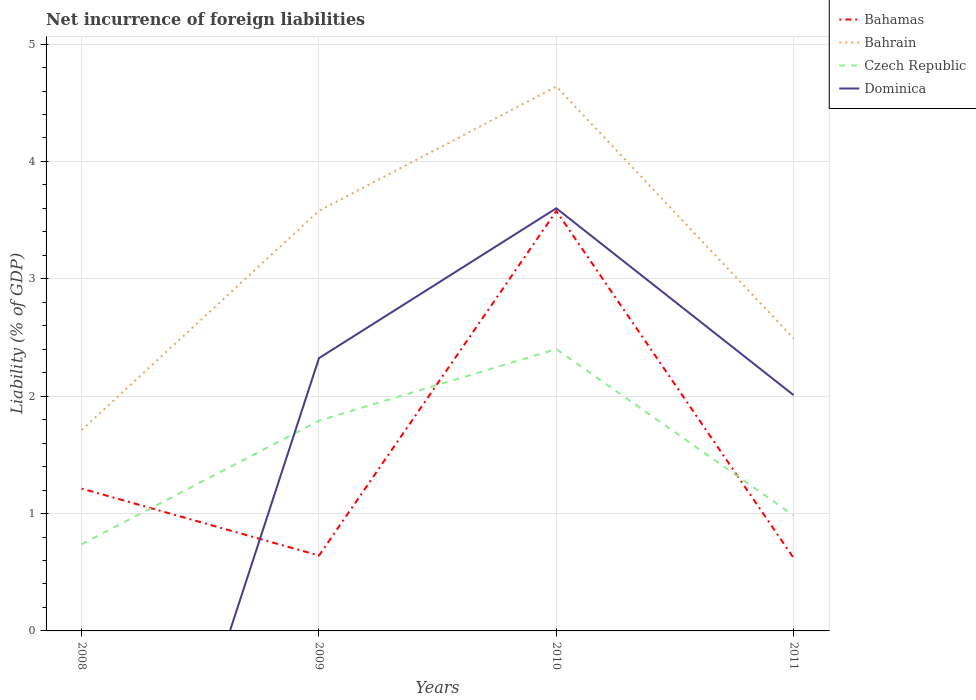How many different coloured lines are there?
Ensure brevity in your answer.  4. Is the number of lines equal to the number of legend labels?
Offer a very short reply. No. Across all years, what is the maximum net incurrence of foreign liabilities in Bahrain?
Your answer should be very brief. 1.71. What is the total net incurrence of foreign liabilities in Bahrain in the graph?
Offer a very short reply. -0.78. What is the difference between the highest and the second highest net incurrence of foreign liabilities in Bahrain?
Offer a terse response. 2.93. Is the net incurrence of foreign liabilities in Bahrain strictly greater than the net incurrence of foreign liabilities in Bahamas over the years?
Keep it short and to the point. No. How many lines are there?
Provide a short and direct response. 4. How many years are there in the graph?
Keep it short and to the point. 4. Does the graph contain grids?
Make the answer very short. Yes. Where does the legend appear in the graph?
Your answer should be very brief. Top right. How are the legend labels stacked?
Make the answer very short. Vertical. What is the title of the graph?
Provide a short and direct response. Net incurrence of foreign liabilities. Does "French Polynesia" appear as one of the legend labels in the graph?
Offer a terse response. No. What is the label or title of the Y-axis?
Your response must be concise. Liability (% of GDP). What is the Liability (% of GDP) of Bahamas in 2008?
Provide a short and direct response. 1.21. What is the Liability (% of GDP) of Bahrain in 2008?
Your response must be concise. 1.71. What is the Liability (% of GDP) of Czech Republic in 2008?
Give a very brief answer. 0.74. What is the Liability (% of GDP) in Dominica in 2008?
Make the answer very short. 0. What is the Liability (% of GDP) in Bahamas in 2009?
Ensure brevity in your answer.  0.64. What is the Liability (% of GDP) in Bahrain in 2009?
Your response must be concise. 3.58. What is the Liability (% of GDP) in Czech Republic in 2009?
Provide a succinct answer. 1.79. What is the Liability (% of GDP) in Dominica in 2009?
Give a very brief answer. 2.32. What is the Liability (% of GDP) in Bahamas in 2010?
Your answer should be very brief. 3.58. What is the Liability (% of GDP) of Bahrain in 2010?
Give a very brief answer. 4.64. What is the Liability (% of GDP) of Czech Republic in 2010?
Provide a short and direct response. 2.4. What is the Liability (% of GDP) in Dominica in 2010?
Offer a terse response. 3.6. What is the Liability (% of GDP) in Bahamas in 2011?
Your answer should be compact. 0.62. What is the Liability (% of GDP) of Bahrain in 2011?
Ensure brevity in your answer.  2.49. What is the Liability (% of GDP) in Czech Republic in 2011?
Provide a succinct answer. 0.98. What is the Liability (% of GDP) of Dominica in 2011?
Ensure brevity in your answer.  2.01. Across all years, what is the maximum Liability (% of GDP) of Bahamas?
Ensure brevity in your answer.  3.58. Across all years, what is the maximum Liability (% of GDP) of Bahrain?
Your response must be concise. 4.64. Across all years, what is the maximum Liability (% of GDP) in Czech Republic?
Give a very brief answer. 2.4. Across all years, what is the maximum Liability (% of GDP) of Dominica?
Your answer should be very brief. 3.6. Across all years, what is the minimum Liability (% of GDP) in Bahamas?
Provide a short and direct response. 0.62. Across all years, what is the minimum Liability (% of GDP) of Bahrain?
Your response must be concise. 1.71. Across all years, what is the minimum Liability (% of GDP) of Czech Republic?
Provide a short and direct response. 0.74. What is the total Liability (% of GDP) in Bahamas in the graph?
Ensure brevity in your answer.  6.05. What is the total Liability (% of GDP) in Bahrain in the graph?
Ensure brevity in your answer.  12.42. What is the total Liability (% of GDP) in Czech Republic in the graph?
Give a very brief answer. 5.91. What is the total Liability (% of GDP) of Dominica in the graph?
Provide a short and direct response. 7.93. What is the difference between the Liability (% of GDP) of Bahamas in 2008 and that in 2009?
Your answer should be very brief. 0.57. What is the difference between the Liability (% of GDP) of Bahrain in 2008 and that in 2009?
Keep it short and to the point. -1.87. What is the difference between the Liability (% of GDP) of Czech Republic in 2008 and that in 2009?
Your response must be concise. -1.05. What is the difference between the Liability (% of GDP) of Bahamas in 2008 and that in 2010?
Ensure brevity in your answer.  -2.36. What is the difference between the Liability (% of GDP) of Bahrain in 2008 and that in 2010?
Your answer should be very brief. -2.93. What is the difference between the Liability (% of GDP) of Czech Republic in 2008 and that in 2010?
Make the answer very short. -1.66. What is the difference between the Liability (% of GDP) in Bahamas in 2008 and that in 2011?
Your response must be concise. 0.59. What is the difference between the Liability (% of GDP) of Bahrain in 2008 and that in 2011?
Make the answer very short. -0.78. What is the difference between the Liability (% of GDP) of Czech Republic in 2008 and that in 2011?
Your answer should be very brief. -0.25. What is the difference between the Liability (% of GDP) of Bahamas in 2009 and that in 2010?
Give a very brief answer. -2.94. What is the difference between the Liability (% of GDP) in Bahrain in 2009 and that in 2010?
Your answer should be compact. -1.06. What is the difference between the Liability (% of GDP) of Czech Republic in 2009 and that in 2010?
Provide a short and direct response. -0.61. What is the difference between the Liability (% of GDP) of Dominica in 2009 and that in 2010?
Ensure brevity in your answer.  -1.28. What is the difference between the Liability (% of GDP) in Bahamas in 2009 and that in 2011?
Your answer should be compact. 0.02. What is the difference between the Liability (% of GDP) of Bahrain in 2009 and that in 2011?
Provide a short and direct response. 1.09. What is the difference between the Liability (% of GDP) in Czech Republic in 2009 and that in 2011?
Give a very brief answer. 0.81. What is the difference between the Liability (% of GDP) in Dominica in 2009 and that in 2011?
Give a very brief answer. 0.32. What is the difference between the Liability (% of GDP) in Bahamas in 2010 and that in 2011?
Make the answer very short. 2.96. What is the difference between the Liability (% of GDP) of Bahrain in 2010 and that in 2011?
Make the answer very short. 2.15. What is the difference between the Liability (% of GDP) in Czech Republic in 2010 and that in 2011?
Your response must be concise. 1.42. What is the difference between the Liability (% of GDP) in Dominica in 2010 and that in 2011?
Offer a terse response. 1.59. What is the difference between the Liability (% of GDP) in Bahamas in 2008 and the Liability (% of GDP) in Bahrain in 2009?
Your answer should be compact. -2.37. What is the difference between the Liability (% of GDP) in Bahamas in 2008 and the Liability (% of GDP) in Czech Republic in 2009?
Give a very brief answer. -0.58. What is the difference between the Liability (% of GDP) in Bahamas in 2008 and the Liability (% of GDP) in Dominica in 2009?
Your answer should be compact. -1.11. What is the difference between the Liability (% of GDP) in Bahrain in 2008 and the Liability (% of GDP) in Czech Republic in 2009?
Ensure brevity in your answer.  -0.08. What is the difference between the Liability (% of GDP) of Bahrain in 2008 and the Liability (% of GDP) of Dominica in 2009?
Your answer should be very brief. -0.61. What is the difference between the Liability (% of GDP) in Czech Republic in 2008 and the Liability (% of GDP) in Dominica in 2009?
Your response must be concise. -1.59. What is the difference between the Liability (% of GDP) of Bahamas in 2008 and the Liability (% of GDP) of Bahrain in 2010?
Offer a very short reply. -3.43. What is the difference between the Liability (% of GDP) in Bahamas in 2008 and the Liability (% of GDP) in Czech Republic in 2010?
Your response must be concise. -1.19. What is the difference between the Liability (% of GDP) of Bahamas in 2008 and the Liability (% of GDP) of Dominica in 2010?
Provide a succinct answer. -2.39. What is the difference between the Liability (% of GDP) in Bahrain in 2008 and the Liability (% of GDP) in Czech Republic in 2010?
Ensure brevity in your answer.  -0.69. What is the difference between the Liability (% of GDP) of Bahrain in 2008 and the Liability (% of GDP) of Dominica in 2010?
Keep it short and to the point. -1.89. What is the difference between the Liability (% of GDP) of Czech Republic in 2008 and the Liability (% of GDP) of Dominica in 2010?
Make the answer very short. -2.86. What is the difference between the Liability (% of GDP) in Bahamas in 2008 and the Liability (% of GDP) in Bahrain in 2011?
Your response must be concise. -1.28. What is the difference between the Liability (% of GDP) of Bahamas in 2008 and the Liability (% of GDP) of Czech Republic in 2011?
Make the answer very short. 0.23. What is the difference between the Liability (% of GDP) in Bahamas in 2008 and the Liability (% of GDP) in Dominica in 2011?
Provide a succinct answer. -0.8. What is the difference between the Liability (% of GDP) in Bahrain in 2008 and the Liability (% of GDP) in Czech Republic in 2011?
Your answer should be compact. 0.73. What is the difference between the Liability (% of GDP) of Bahrain in 2008 and the Liability (% of GDP) of Dominica in 2011?
Your response must be concise. -0.3. What is the difference between the Liability (% of GDP) in Czech Republic in 2008 and the Liability (% of GDP) in Dominica in 2011?
Make the answer very short. -1.27. What is the difference between the Liability (% of GDP) in Bahamas in 2009 and the Liability (% of GDP) in Bahrain in 2010?
Your response must be concise. -4. What is the difference between the Liability (% of GDP) in Bahamas in 2009 and the Liability (% of GDP) in Czech Republic in 2010?
Keep it short and to the point. -1.76. What is the difference between the Liability (% of GDP) in Bahamas in 2009 and the Liability (% of GDP) in Dominica in 2010?
Make the answer very short. -2.96. What is the difference between the Liability (% of GDP) in Bahrain in 2009 and the Liability (% of GDP) in Czech Republic in 2010?
Your response must be concise. 1.18. What is the difference between the Liability (% of GDP) of Bahrain in 2009 and the Liability (% of GDP) of Dominica in 2010?
Provide a succinct answer. -0.02. What is the difference between the Liability (% of GDP) of Czech Republic in 2009 and the Liability (% of GDP) of Dominica in 2010?
Keep it short and to the point. -1.81. What is the difference between the Liability (% of GDP) in Bahamas in 2009 and the Liability (% of GDP) in Bahrain in 2011?
Provide a short and direct response. -1.85. What is the difference between the Liability (% of GDP) in Bahamas in 2009 and the Liability (% of GDP) in Czech Republic in 2011?
Give a very brief answer. -0.34. What is the difference between the Liability (% of GDP) of Bahamas in 2009 and the Liability (% of GDP) of Dominica in 2011?
Offer a very short reply. -1.37. What is the difference between the Liability (% of GDP) in Bahrain in 2009 and the Liability (% of GDP) in Czech Republic in 2011?
Offer a terse response. 2.6. What is the difference between the Liability (% of GDP) of Bahrain in 2009 and the Liability (% of GDP) of Dominica in 2011?
Offer a terse response. 1.57. What is the difference between the Liability (% of GDP) in Czech Republic in 2009 and the Liability (% of GDP) in Dominica in 2011?
Offer a very short reply. -0.22. What is the difference between the Liability (% of GDP) in Bahamas in 2010 and the Liability (% of GDP) in Bahrain in 2011?
Provide a short and direct response. 1.09. What is the difference between the Liability (% of GDP) in Bahamas in 2010 and the Liability (% of GDP) in Czech Republic in 2011?
Your answer should be very brief. 2.59. What is the difference between the Liability (% of GDP) in Bahamas in 2010 and the Liability (% of GDP) in Dominica in 2011?
Provide a short and direct response. 1.57. What is the difference between the Liability (% of GDP) in Bahrain in 2010 and the Liability (% of GDP) in Czech Republic in 2011?
Make the answer very short. 3.65. What is the difference between the Liability (% of GDP) of Bahrain in 2010 and the Liability (% of GDP) of Dominica in 2011?
Offer a terse response. 2.63. What is the difference between the Liability (% of GDP) in Czech Republic in 2010 and the Liability (% of GDP) in Dominica in 2011?
Offer a terse response. 0.39. What is the average Liability (% of GDP) of Bahamas per year?
Keep it short and to the point. 1.51. What is the average Liability (% of GDP) in Bahrain per year?
Make the answer very short. 3.11. What is the average Liability (% of GDP) in Czech Republic per year?
Offer a terse response. 1.48. What is the average Liability (% of GDP) in Dominica per year?
Keep it short and to the point. 1.98. In the year 2008, what is the difference between the Liability (% of GDP) of Bahamas and Liability (% of GDP) of Bahrain?
Keep it short and to the point. -0.5. In the year 2008, what is the difference between the Liability (% of GDP) in Bahamas and Liability (% of GDP) in Czech Republic?
Your answer should be compact. 0.47. In the year 2008, what is the difference between the Liability (% of GDP) of Bahrain and Liability (% of GDP) of Czech Republic?
Make the answer very short. 0.97. In the year 2009, what is the difference between the Liability (% of GDP) of Bahamas and Liability (% of GDP) of Bahrain?
Your response must be concise. -2.94. In the year 2009, what is the difference between the Liability (% of GDP) in Bahamas and Liability (% of GDP) in Czech Republic?
Your answer should be very brief. -1.15. In the year 2009, what is the difference between the Liability (% of GDP) in Bahamas and Liability (% of GDP) in Dominica?
Offer a very short reply. -1.68. In the year 2009, what is the difference between the Liability (% of GDP) in Bahrain and Liability (% of GDP) in Czech Republic?
Provide a short and direct response. 1.79. In the year 2009, what is the difference between the Liability (% of GDP) in Bahrain and Liability (% of GDP) in Dominica?
Make the answer very short. 1.26. In the year 2009, what is the difference between the Liability (% of GDP) in Czech Republic and Liability (% of GDP) in Dominica?
Your answer should be compact. -0.53. In the year 2010, what is the difference between the Liability (% of GDP) in Bahamas and Liability (% of GDP) in Bahrain?
Provide a succinct answer. -1.06. In the year 2010, what is the difference between the Liability (% of GDP) of Bahamas and Liability (% of GDP) of Czech Republic?
Provide a succinct answer. 1.18. In the year 2010, what is the difference between the Liability (% of GDP) of Bahamas and Liability (% of GDP) of Dominica?
Ensure brevity in your answer.  -0.02. In the year 2010, what is the difference between the Liability (% of GDP) of Bahrain and Liability (% of GDP) of Czech Republic?
Keep it short and to the point. 2.24. In the year 2010, what is the difference between the Liability (% of GDP) of Bahrain and Liability (% of GDP) of Dominica?
Make the answer very short. 1.04. In the year 2011, what is the difference between the Liability (% of GDP) in Bahamas and Liability (% of GDP) in Bahrain?
Your answer should be very brief. -1.87. In the year 2011, what is the difference between the Liability (% of GDP) of Bahamas and Liability (% of GDP) of Czech Republic?
Offer a terse response. -0.36. In the year 2011, what is the difference between the Liability (% of GDP) in Bahamas and Liability (% of GDP) in Dominica?
Provide a succinct answer. -1.39. In the year 2011, what is the difference between the Liability (% of GDP) in Bahrain and Liability (% of GDP) in Czech Republic?
Provide a short and direct response. 1.51. In the year 2011, what is the difference between the Liability (% of GDP) of Bahrain and Liability (% of GDP) of Dominica?
Ensure brevity in your answer.  0.48. In the year 2011, what is the difference between the Liability (% of GDP) of Czech Republic and Liability (% of GDP) of Dominica?
Your response must be concise. -1.03. What is the ratio of the Liability (% of GDP) of Bahamas in 2008 to that in 2009?
Make the answer very short. 1.89. What is the ratio of the Liability (% of GDP) in Bahrain in 2008 to that in 2009?
Your answer should be compact. 0.48. What is the ratio of the Liability (% of GDP) of Czech Republic in 2008 to that in 2009?
Make the answer very short. 0.41. What is the ratio of the Liability (% of GDP) of Bahamas in 2008 to that in 2010?
Offer a terse response. 0.34. What is the ratio of the Liability (% of GDP) of Bahrain in 2008 to that in 2010?
Provide a succinct answer. 0.37. What is the ratio of the Liability (% of GDP) of Czech Republic in 2008 to that in 2010?
Your answer should be very brief. 0.31. What is the ratio of the Liability (% of GDP) in Bahamas in 2008 to that in 2011?
Keep it short and to the point. 1.96. What is the ratio of the Liability (% of GDP) in Bahrain in 2008 to that in 2011?
Give a very brief answer. 0.69. What is the ratio of the Liability (% of GDP) of Czech Republic in 2008 to that in 2011?
Your answer should be compact. 0.75. What is the ratio of the Liability (% of GDP) of Bahamas in 2009 to that in 2010?
Provide a succinct answer. 0.18. What is the ratio of the Liability (% of GDP) in Bahrain in 2009 to that in 2010?
Your answer should be compact. 0.77. What is the ratio of the Liability (% of GDP) in Czech Republic in 2009 to that in 2010?
Your answer should be very brief. 0.75. What is the ratio of the Liability (% of GDP) in Dominica in 2009 to that in 2010?
Provide a succinct answer. 0.65. What is the ratio of the Liability (% of GDP) in Bahamas in 2009 to that in 2011?
Your response must be concise. 1.03. What is the ratio of the Liability (% of GDP) of Bahrain in 2009 to that in 2011?
Your answer should be compact. 1.44. What is the ratio of the Liability (% of GDP) of Czech Republic in 2009 to that in 2011?
Make the answer very short. 1.82. What is the ratio of the Liability (% of GDP) of Dominica in 2009 to that in 2011?
Your answer should be compact. 1.16. What is the ratio of the Liability (% of GDP) of Bahamas in 2010 to that in 2011?
Your answer should be very brief. 5.77. What is the ratio of the Liability (% of GDP) in Bahrain in 2010 to that in 2011?
Your response must be concise. 1.86. What is the ratio of the Liability (% of GDP) of Czech Republic in 2010 to that in 2011?
Make the answer very short. 2.44. What is the ratio of the Liability (% of GDP) of Dominica in 2010 to that in 2011?
Your answer should be compact. 1.79. What is the difference between the highest and the second highest Liability (% of GDP) in Bahamas?
Make the answer very short. 2.36. What is the difference between the highest and the second highest Liability (% of GDP) of Bahrain?
Your answer should be very brief. 1.06. What is the difference between the highest and the second highest Liability (% of GDP) in Czech Republic?
Provide a succinct answer. 0.61. What is the difference between the highest and the second highest Liability (% of GDP) in Dominica?
Offer a terse response. 1.28. What is the difference between the highest and the lowest Liability (% of GDP) in Bahamas?
Ensure brevity in your answer.  2.96. What is the difference between the highest and the lowest Liability (% of GDP) of Bahrain?
Offer a terse response. 2.93. What is the difference between the highest and the lowest Liability (% of GDP) in Czech Republic?
Provide a succinct answer. 1.66. What is the difference between the highest and the lowest Liability (% of GDP) of Dominica?
Your answer should be very brief. 3.6. 